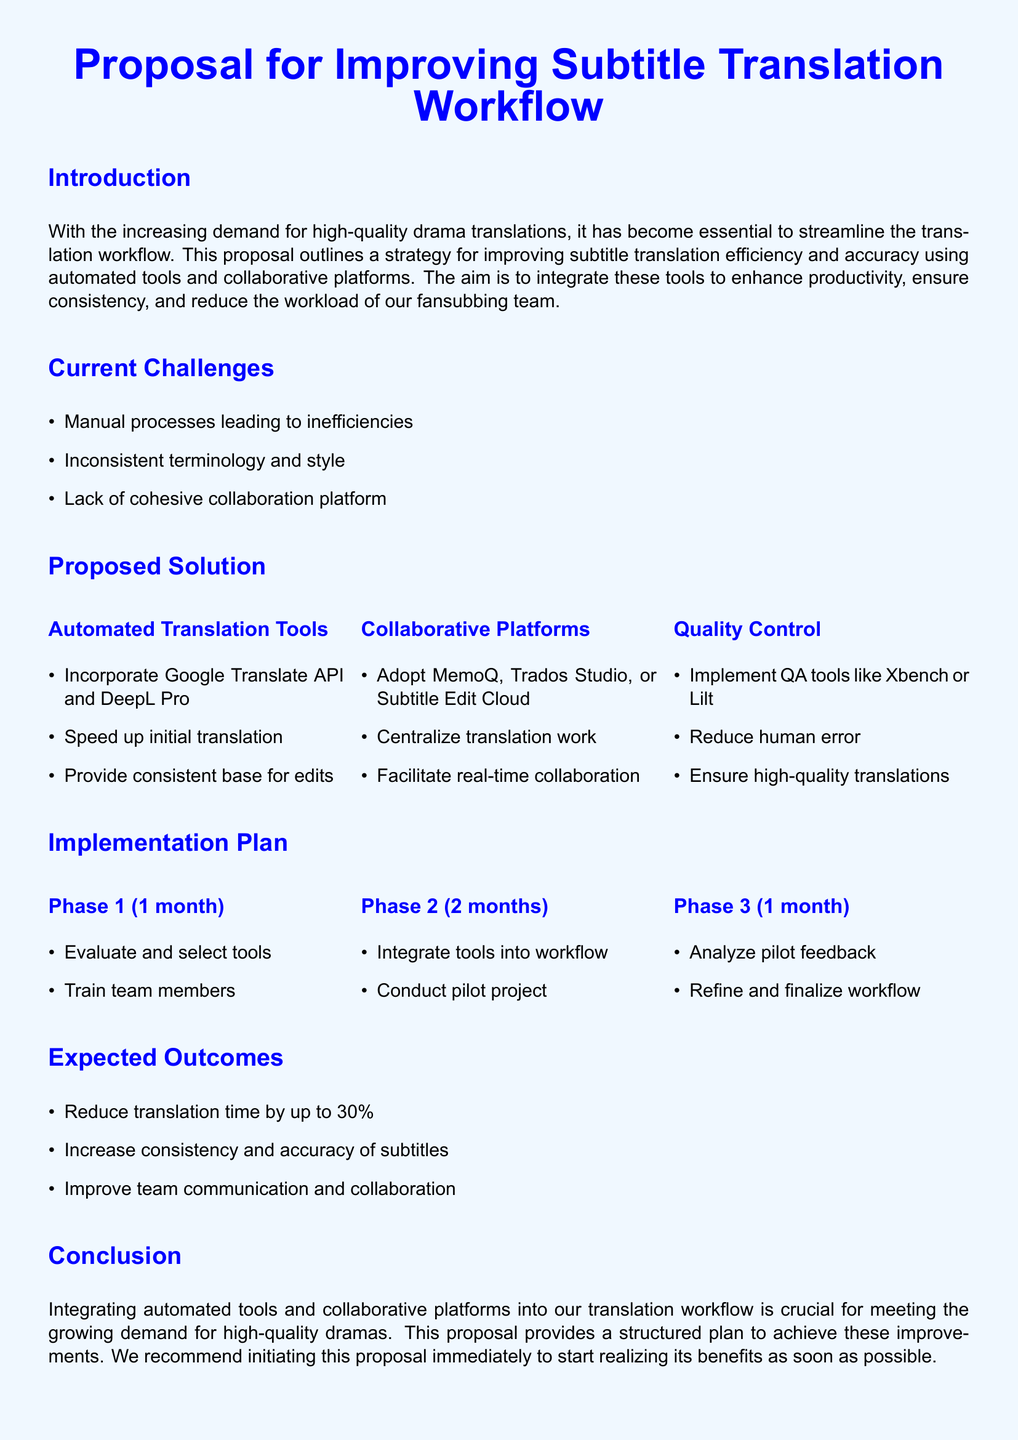What is the main focus of the proposal? The proposal focuses on improving subtitle translation efficiency and accuracy using automated tools and collaborative platforms.
Answer: Improving subtitle translation workflow What is one automated translation tool mentioned in the proposal? The proposal mentions incorporating Google Translate API and DeepL Pro as automated translation tools.
Answer: Google Translate API How long is Phase 1 planned to last? Phase 1 is planned to last for 1 month according to the implementation plan in the proposal.
Answer: 1 month What is the expected reduction in translation time? The expected reduction in translation time is up to 30 percent as stated in the expected outcomes section.
Answer: 30 percent What is one reason for implementing quality control tools? One reason for implementing quality control tools is to reduce human error in translations.
Answer: Reduce human error What platforms are suggested for collaborative work? The proposal suggests adopting MemoQ, Trados Studio, or Subtitle Edit Cloud as collaborative platforms.
Answer: MemoQ, Trados Studio, Subtitle Edit Cloud What is the purpose of the pilot project in Phase 2? The pilot project in Phase 2 aims to integrate tools into the workflow and test their effectiveness.
Answer: Test effectiveness What is the final step in the implementation plan? The final step in the implementation plan is to refine and finalize the workflow based on pilot feedback.
Answer: Refine and finalize workflow 